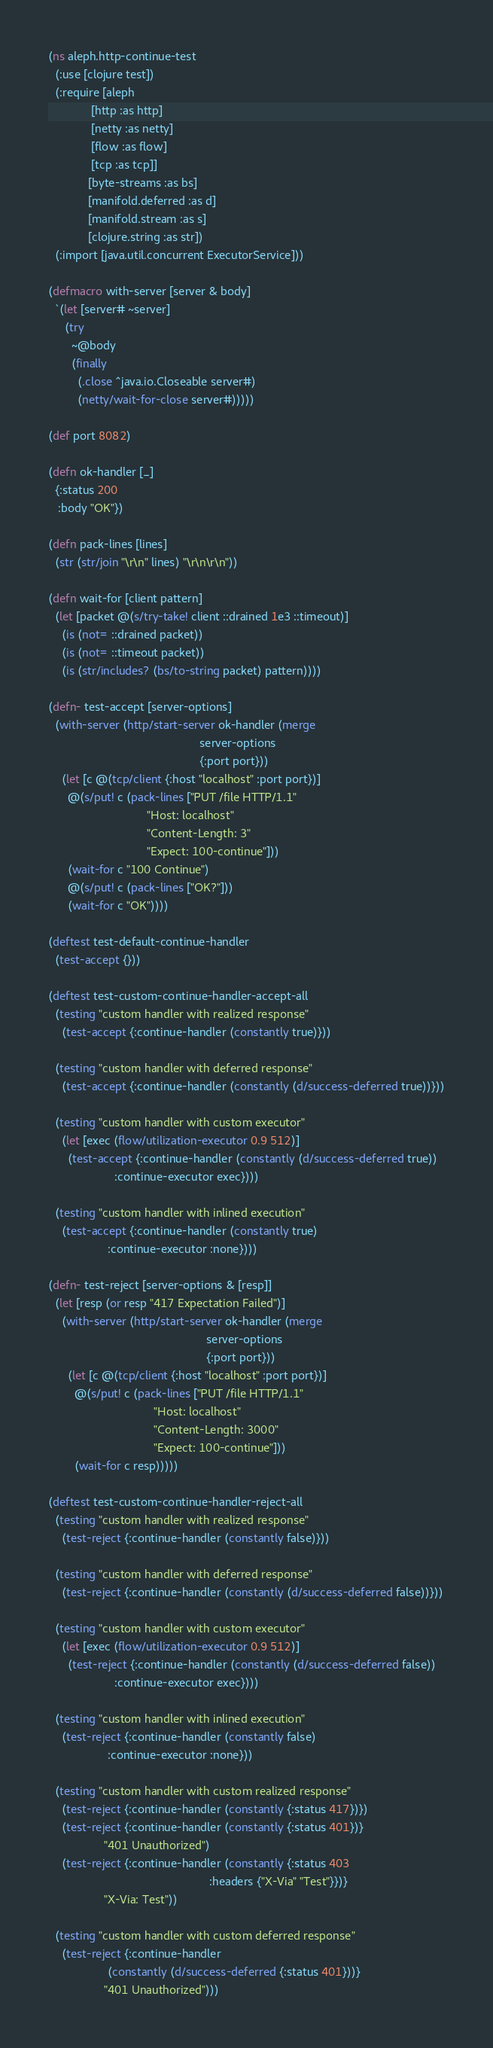<code> <loc_0><loc_0><loc_500><loc_500><_Clojure_>(ns aleph.http-continue-test
  (:use [clojure test])
  (:require [aleph
             [http :as http]
             [netty :as netty]
             [flow :as flow]
             [tcp :as tcp]]
            [byte-streams :as bs]
            [manifold.deferred :as d]
            [manifold.stream :as s]
            [clojure.string :as str])
  (:import [java.util.concurrent ExecutorService]))

(defmacro with-server [server & body]
  `(let [server# ~server]
     (try
       ~@body
       (finally
         (.close ^java.io.Closeable server#)
         (netty/wait-for-close server#)))))

(def port 8082)

(defn ok-handler [_]
  {:status 200
   :body "OK"})

(defn pack-lines [lines]
  (str (str/join "\r\n" lines) "\r\n\r\n"))

(defn wait-for [client pattern]
  (let [packet @(s/try-take! client ::drained 1e3 ::timeout)]
    (is (not= ::drained packet))
    (is (not= ::timeout packet))
    (is (str/includes? (bs/to-string packet) pattern))))

(defn- test-accept [server-options]
  (with-server (http/start-server ok-handler (merge
                                              server-options
                                              {:port port}))
    (let [c @(tcp/client {:host "localhost" :port port})]
      @(s/put! c (pack-lines ["PUT /file HTTP/1.1"
                              "Host: localhost"
                              "Content-Length: 3"
                              "Expect: 100-continue"]))
      (wait-for c "100 Continue")
      @(s/put! c (pack-lines ["OK?"]))
      (wait-for c "OK"))))

(deftest test-default-continue-handler
  (test-accept {}))

(deftest test-custom-continue-handler-accept-all
  (testing "custom handler with realized response"
    (test-accept {:continue-handler (constantly true)}))

  (testing "custom handler with deferred response"
    (test-accept {:continue-handler (constantly (d/success-deferred true))}))

  (testing "custom handler with custom executor"
    (let [exec (flow/utilization-executor 0.9 512)]
      (test-accept {:continue-handler (constantly (d/success-deferred true))
                    :continue-executor exec})))

  (testing "custom handler with inlined execution"
    (test-accept {:continue-handler (constantly true)
                  :continue-executor :none})))

(defn- test-reject [server-options & [resp]]
  (let [resp (or resp "417 Expectation Failed")]
    (with-server (http/start-server ok-handler (merge
                                                server-options
                                                {:port port}))
      (let [c @(tcp/client {:host "localhost" :port port})]
        @(s/put! c (pack-lines ["PUT /file HTTP/1.1"
                                "Host: localhost"
                                "Content-Length: 3000"
                                "Expect: 100-continue"]))
        (wait-for c resp)))))

(deftest test-custom-continue-handler-reject-all
  (testing "custom handler with realized response"
    (test-reject {:continue-handler (constantly false)}))

  (testing "custom handler with deferred response"
    (test-reject {:continue-handler (constantly (d/success-deferred false))}))

  (testing "custom handler with custom executor"
    (let [exec (flow/utilization-executor 0.9 512)]
      (test-reject {:continue-handler (constantly (d/success-deferred false))
                    :continue-executor exec})))

  (testing "custom handler with inlined execution"
    (test-reject {:continue-handler (constantly false)
                  :continue-executor :none}))

  (testing "custom handler with custom realized response"
    (test-reject {:continue-handler (constantly {:status 417})})
    (test-reject {:continue-handler (constantly {:status 401})}
                 "401 Unauthorized")
    (test-reject {:continue-handler (constantly {:status 403
                                                 :headers {"X-Via" "Test"}})}
                 "X-Via: Test"))

  (testing "custom handler with custom deferred response"
    (test-reject {:continue-handler
                  (constantly (d/success-deferred {:status 401}))}
                 "401 Unauthorized")))
</code> 